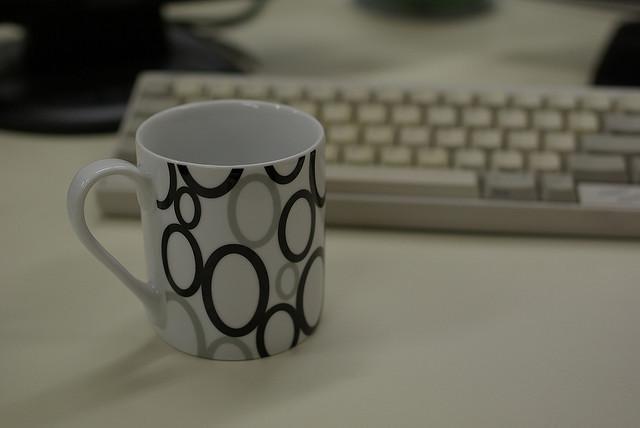How many people will the pizza likely serve?
Give a very brief answer. 0. 